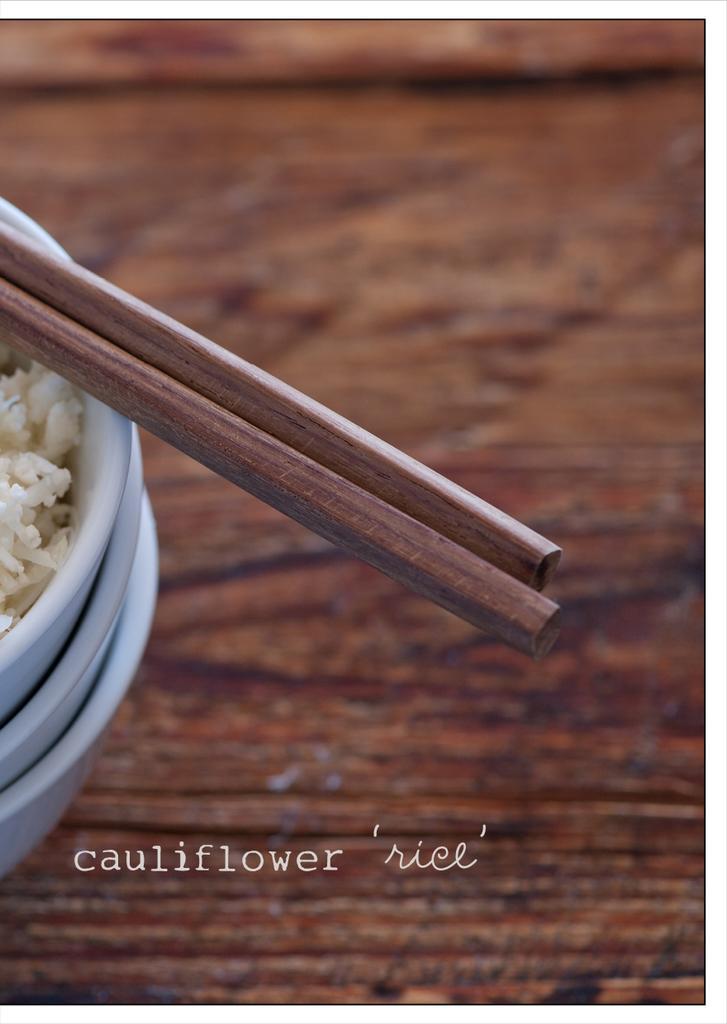Can you describe this image briefly? In this picture, this is a wooden table on the table there are three bowls with food and wooden chopsticks. On the image there is a watermark. 